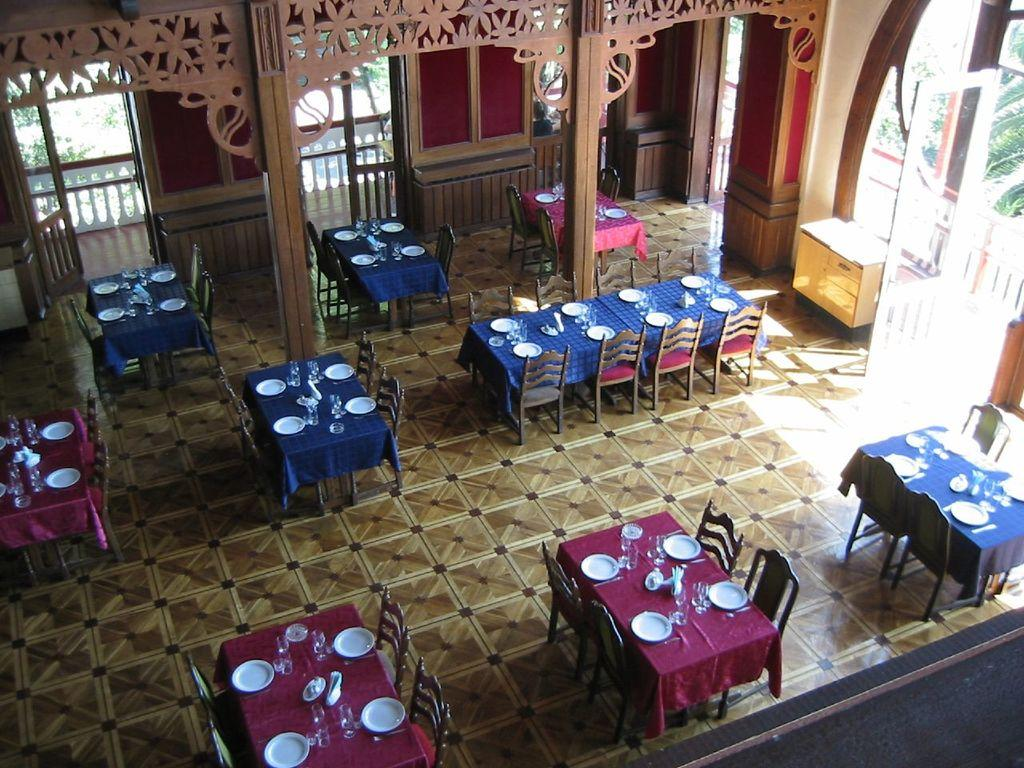What type of view is provided in the image? The image shows a top view of a room. What can be seen on the floor in the room? Cement grills are visible on the floor in the room. What type of furniture is present in the room? There are chairs and tables in the room. What items are used for eating and drinking in the room? Crockery and cutlery are present in the room. What type of storage is available in the room? There are cupboards in the room. What part of the room's structure is visible? Walls are visible in the room. What type of powder is sprinkled on the chairs in the image? There is no powder visible on the chairs in the image. What type of fork is used to select items from the cupboards in the image? There is no fork present in the image, and the cupboards do not require a fork for selection. 